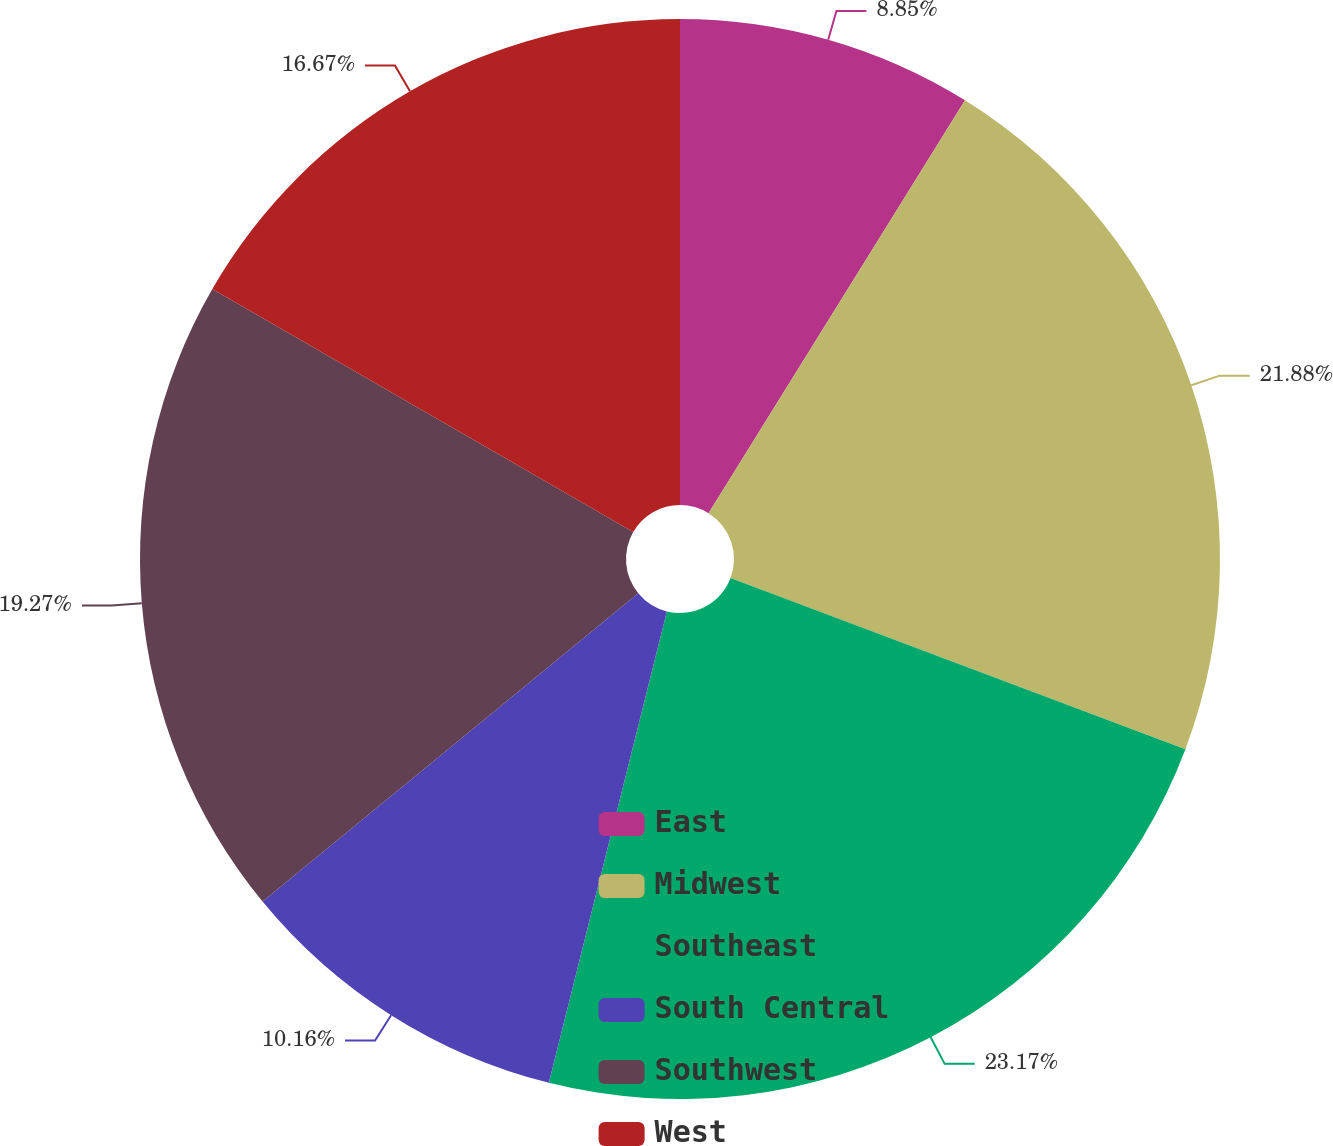<chart> <loc_0><loc_0><loc_500><loc_500><pie_chart><fcel>East<fcel>Midwest<fcel>Southeast<fcel>South Central<fcel>Southwest<fcel>West<nl><fcel>8.85%<fcel>21.88%<fcel>23.18%<fcel>10.16%<fcel>19.27%<fcel>16.67%<nl></chart> 